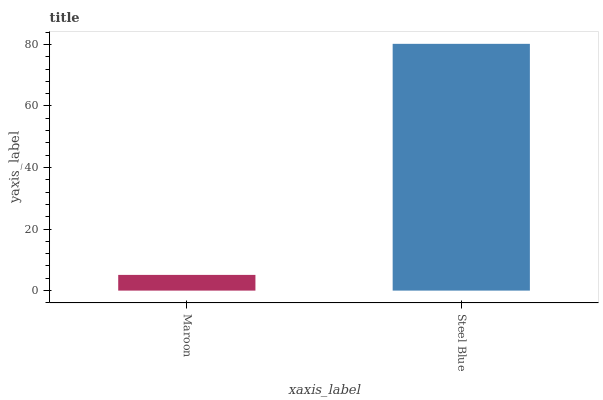Is Maroon the minimum?
Answer yes or no. Yes. Is Steel Blue the maximum?
Answer yes or no. Yes. Is Steel Blue the minimum?
Answer yes or no. No. Is Steel Blue greater than Maroon?
Answer yes or no. Yes. Is Maroon less than Steel Blue?
Answer yes or no. Yes. Is Maroon greater than Steel Blue?
Answer yes or no. No. Is Steel Blue less than Maroon?
Answer yes or no. No. Is Steel Blue the high median?
Answer yes or no. Yes. Is Maroon the low median?
Answer yes or no. Yes. Is Maroon the high median?
Answer yes or no. No. Is Steel Blue the low median?
Answer yes or no. No. 